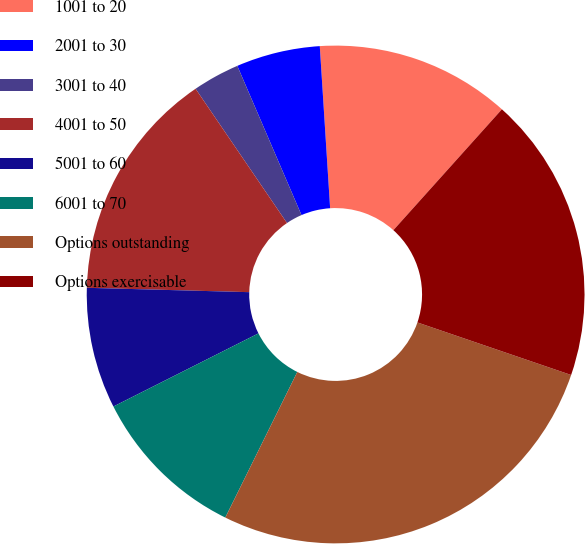<chart> <loc_0><loc_0><loc_500><loc_500><pie_chart><fcel>1001 to 20<fcel>2001 to 30<fcel>3001 to 40<fcel>4001 to 50<fcel>5001 to 60<fcel>6001 to 70<fcel>Options outstanding<fcel>Options exercisable<nl><fcel>12.66%<fcel>5.45%<fcel>3.05%<fcel>15.06%<fcel>7.86%<fcel>10.26%<fcel>27.07%<fcel>18.6%<nl></chart> 